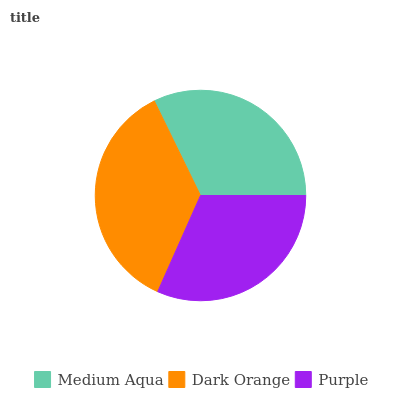Is Purple the minimum?
Answer yes or no. Yes. Is Dark Orange the maximum?
Answer yes or no. Yes. Is Dark Orange the minimum?
Answer yes or no. No. Is Purple the maximum?
Answer yes or no. No. Is Dark Orange greater than Purple?
Answer yes or no. Yes. Is Purple less than Dark Orange?
Answer yes or no. Yes. Is Purple greater than Dark Orange?
Answer yes or no. No. Is Dark Orange less than Purple?
Answer yes or no. No. Is Medium Aqua the high median?
Answer yes or no. Yes. Is Medium Aqua the low median?
Answer yes or no. Yes. Is Purple the high median?
Answer yes or no. No. Is Purple the low median?
Answer yes or no. No. 